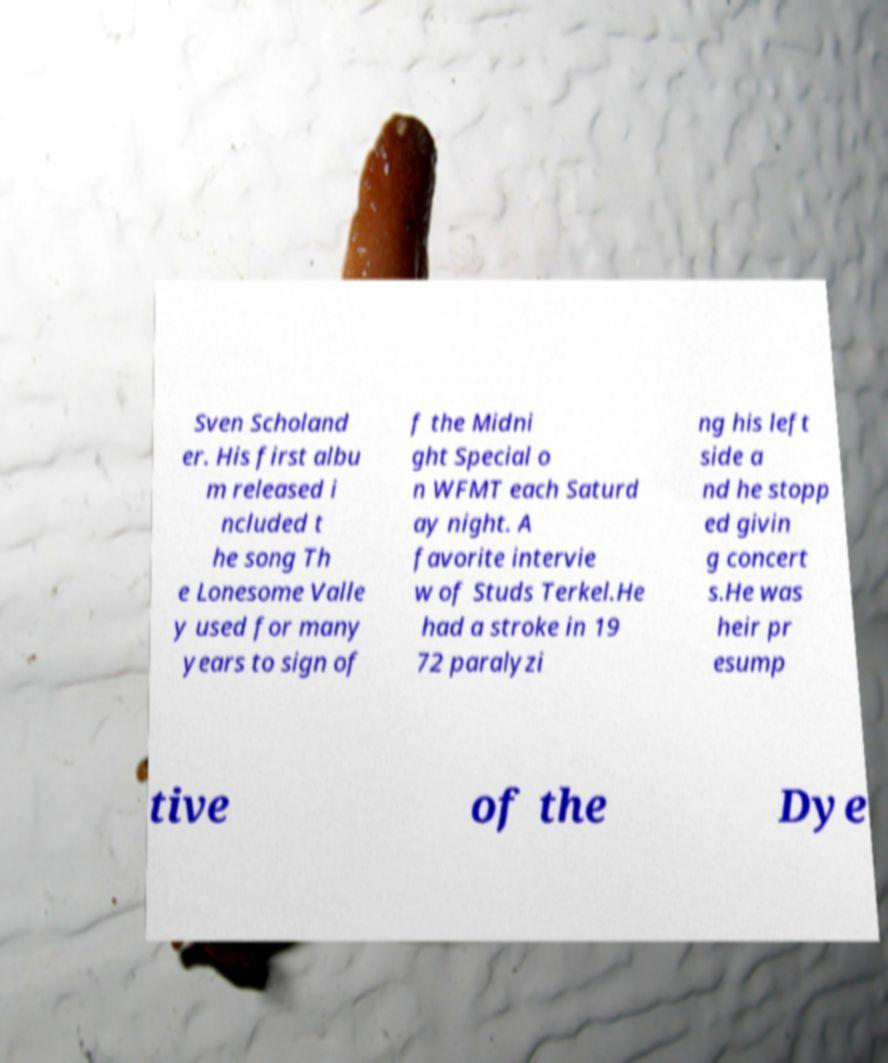I need the written content from this picture converted into text. Can you do that? Sven Scholand er. His first albu m released i ncluded t he song Th e Lonesome Valle y used for many years to sign of f the Midni ght Special o n WFMT each Saturd ay night. A favorite intervie w of Studs Terkel.He had a stroke in 19 72 paralyzi ng his left side a nd he stopp ed givin g concert s.He was heir pr esump tive of the Dye 